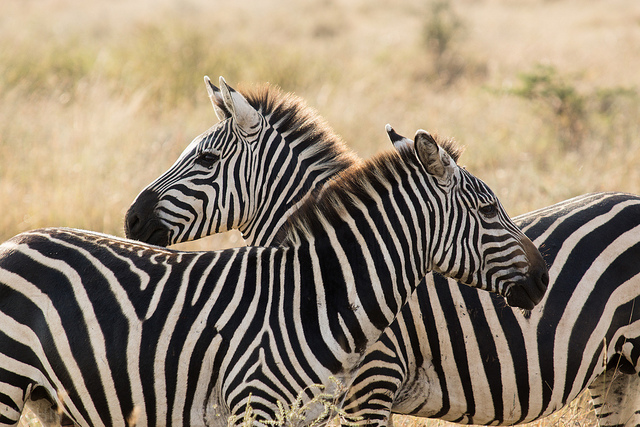Are these animals in their natural habitat? Yes, these zebras are in their natural habitat. 